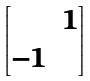Convert formula to latex. <formula><loc_0><loc_0><loc_500><loc_500>\begin{bmatrix} & 1 \\ - 1 & \end{bmatrix}</formula> 